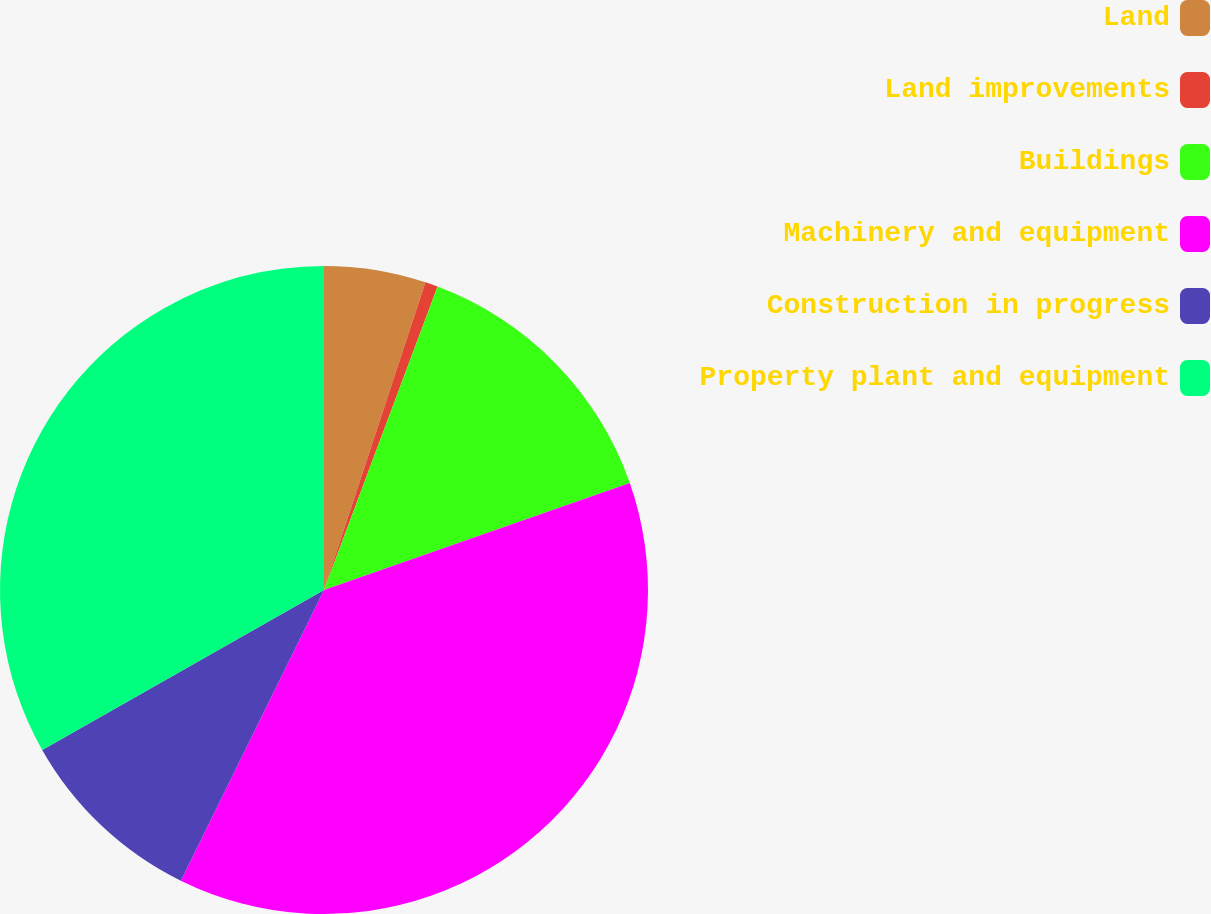<chart> <loc_0><loc_0><loc_500><loc_500><pie_chart><fcel>Land<fcel>Land improvements<fcel>Buildings<fcel>Machinery and equipment<fcel>Construction in progress<fcel>Property plant and equipment<nl><fcel>5.07%<fcel>0.63%<fcel>13.94%<fcel>37.64%<fcel>9.5%<fcel>33.21%<nl></chart> 